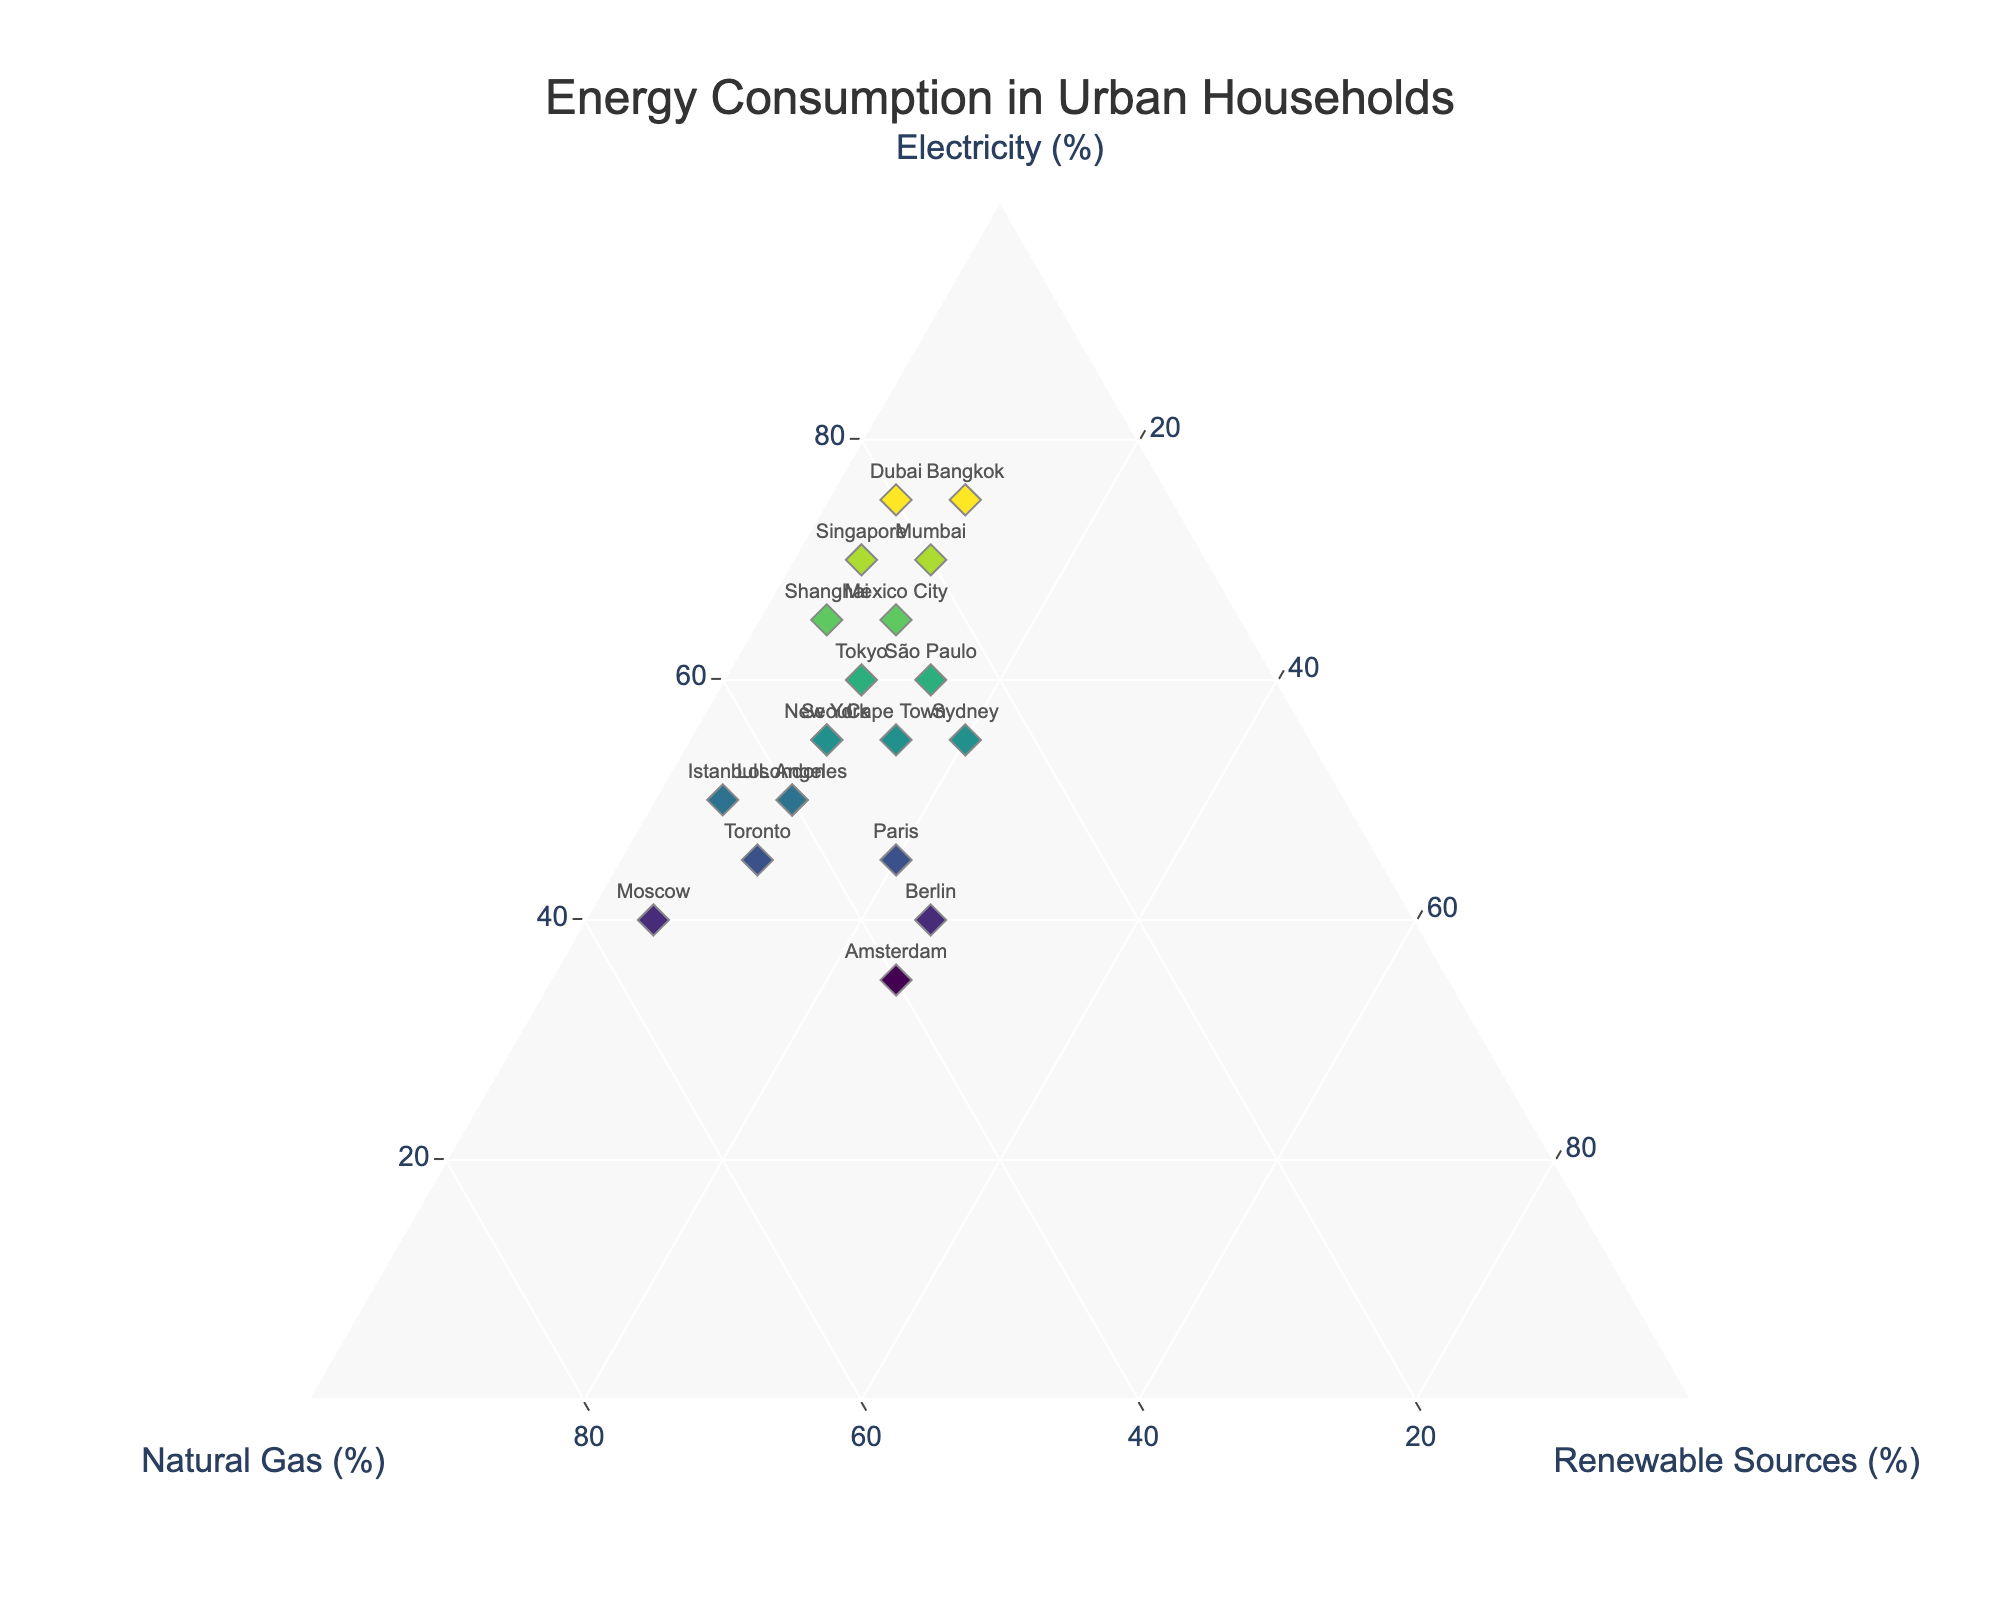What is the title of the ternary plot? The title can be seen prominently at the top of the plot. It summarizes the content of the plot, helping viewers immediately understand what the visual represents.
Answer: Energy Consumption in Urban Households Which city relies most on renewable sources? By looking at the ternary plot, identify the city that has the highest value on the axis labeled "Renewable Sources (%)".
Answer: Berlin What percentage of Mumbai's energy consumption comes from natural gas? Hovering over the point marked "Mumbai" will display a tooltip showing the exact percentage for each energy type. Mumbai's natural gas value can be directly read from there.
Answer: 20% Which cities have the same percentage of renewable sources? By comparing the "Renewable Sources" axis values, we can see which cities share the same percentage.
Answer: Tokyo, New York, London, Los Angeles, Toronto, Seoul (10%) Compare the electricity consumption percentages between Dubai and Mumbai. Which city has a higher percentage and by how much? Identify the "Electricity" percentage for both cities, and then calculate the difference. Dubai has 75%, and Mumbai has 70%. 75% - 70% = 5% difference.
Answer: Dubai, by 5% Which city has the highest percentage of natural gas consumption? Examine the "Natural Gas" axis values directly. The city with the highest percentage will be obvious.
Answer: Moscow How does the overall energy consumption pattern of New York differ from that of Paris in terms of renewable sources? Compare the position of New York with Paris along the "Renewable Sources" axis. New York has 10%, whereas Paris has 20%.
Answer: Paris relies more on renewable sources (20% vs. 10%) What is the average percentage of electricity consumption for Tokyo, Shanghai, and Singapore? Add the electricity percentages for these cities and divide by the number of cities. (60 + 65 + 70) / 3 = 65%
Answer: 65% Find two cities that have exactly the same energy composition percentages for electricity and natural gas. Scan through the plot and hover over each point. Check for pairs of cities that have identical percentages for both energy types.
Answer: Tokyo and São Paulo (60% electricity, 30% natural gas) Among the cities with exactly 25% reliance on renewable sources, which has the least percentage of electricity consumption? Identify the cities with 25% on the renewable sources axis and then compare their electricity percentages.
Answer: Amsterdam 